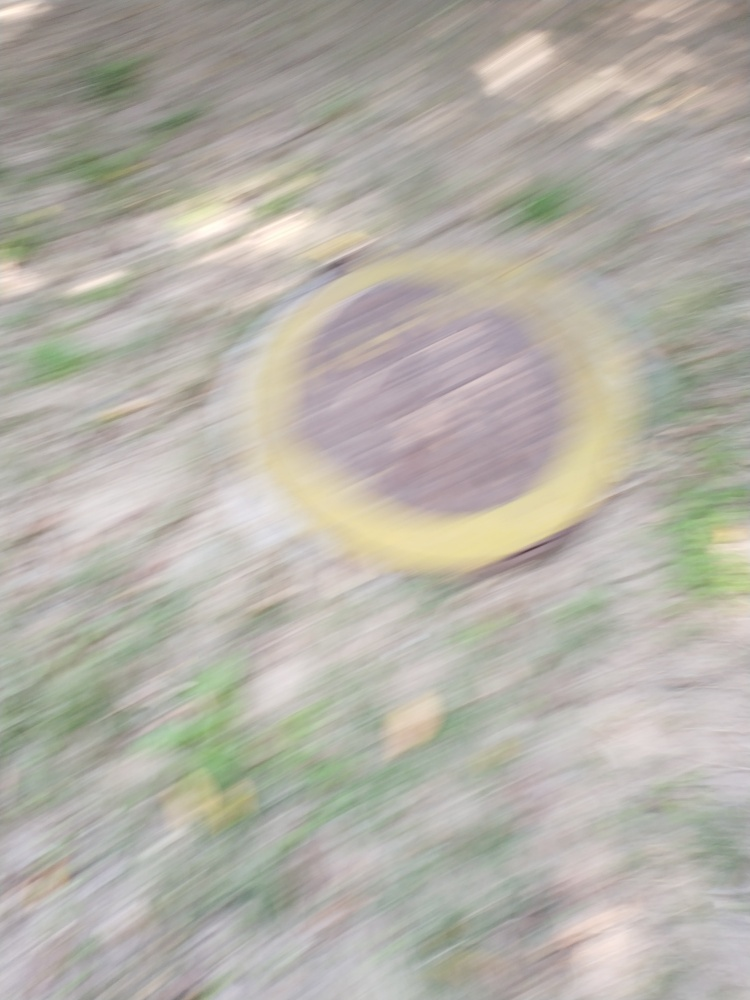What could be the reason for the camera's movement that led to this blurry photo? The blurriness could be the result of an unintentional shake of the hand while taking the photo, especially if a slow shutter speed was used. Alternatively, it could be a deliberate motion blur effect, aimed at conveying speed or movement, although the context of this image makes that seem less likely. 